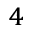Convert formula to latex. <formula><loc_0><loc_0><loc_500><loc_500>^ { 4 }</formula> 